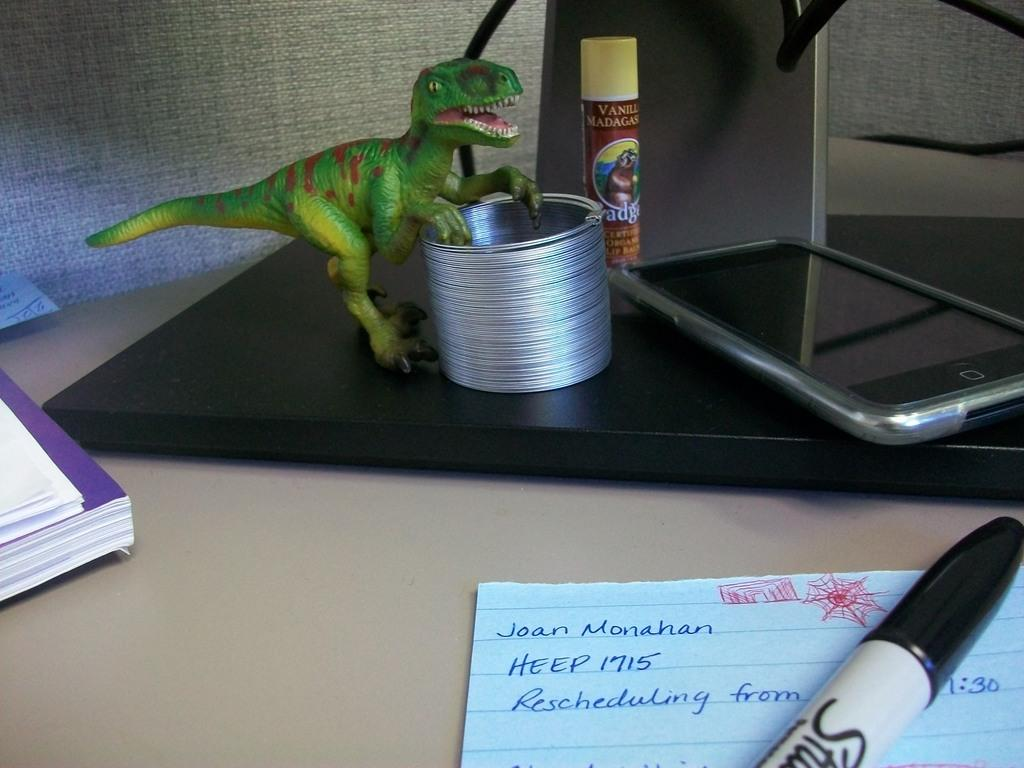What is written on the paper in the image? There is a note written on the paper in the image. What can be used to write on the paper? There is a pen in the image that can be used for writing. What else is visible in the image besides the paper and pen? There is a book, a mobile phone, and a toy in the image, as well as other unspecified items on the surface. How far is the sidewalk from the items in the image? There is no sidewalk present in the image, so it is not possible to determine the distance between the items and a sidewalk. 